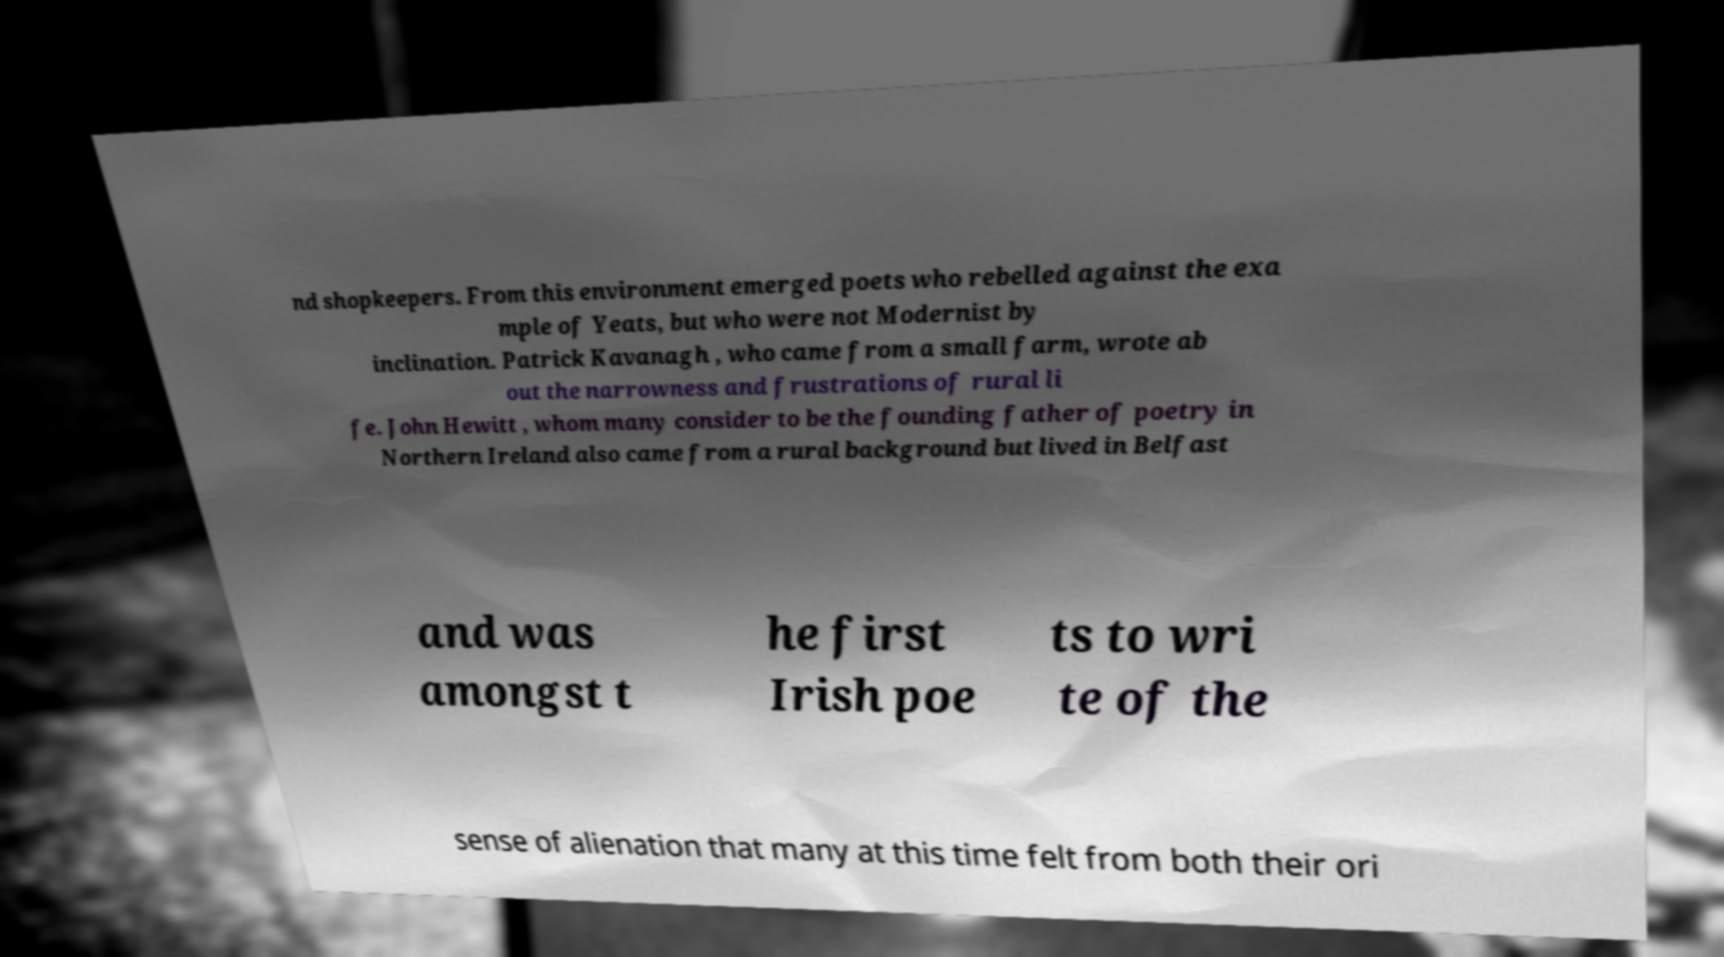There's text embedded in this image that I need extracted. Can you transcribe it verbatim? nd shopkeepers. From this environment emerged poets who rebelled against the exa mple of Yeats, but who were not Modernist by inclination. Patrick Kavanagh , who came from a small farm, wrote ab out the narrowness and frustrations of rural li fe. John Hewitt , whom many consider to be the founding father of poetry in Northern Ireland also came from a rural background but lived in Belfast and was amongst t he first Irish poe ts to wri te of the sense of alienation that many at this time felt from both their ori 